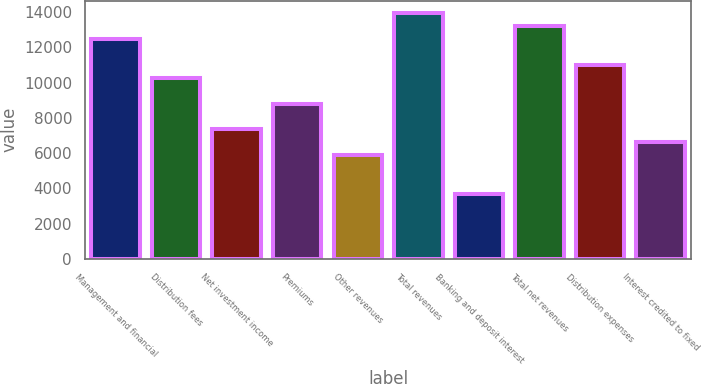Convert chart. <chart><loc_0><loc_0><loc_500><loc_500><bar_chart><fcel>Management and financial<fcel>Distribution fees<fcel>Net investment income<fcel>Premiums<fcel>Other revenues<fcel>Total revenues<fcel>Banking and deposit interest<fcel>Total net revenues<fcel>Distribution expenses<fcel>Interest credited to fixed<nl><fcel>12479.5<fcel>10277.3<fcel>7340.97<fcel>8809.13<fcel>5872.81<fcel>13947.7<fcel>3670.57<fcel>13213.6<fcel>11011.4<fcel>6606.89<nl></chart> 